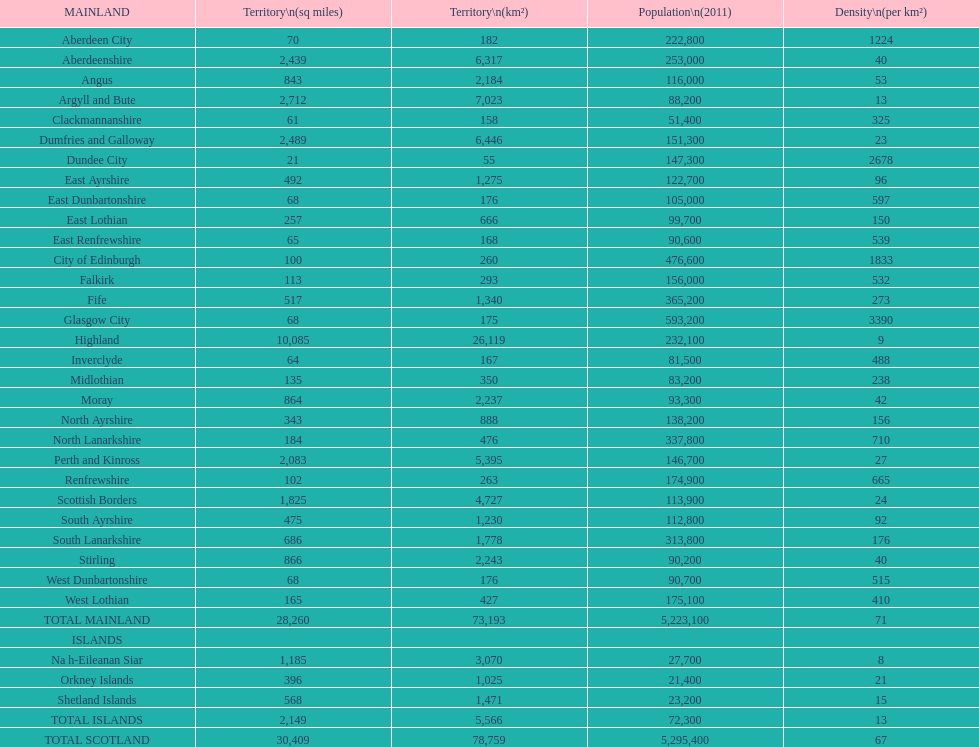How many primary landmasses have populations less than 100,000? 9. 